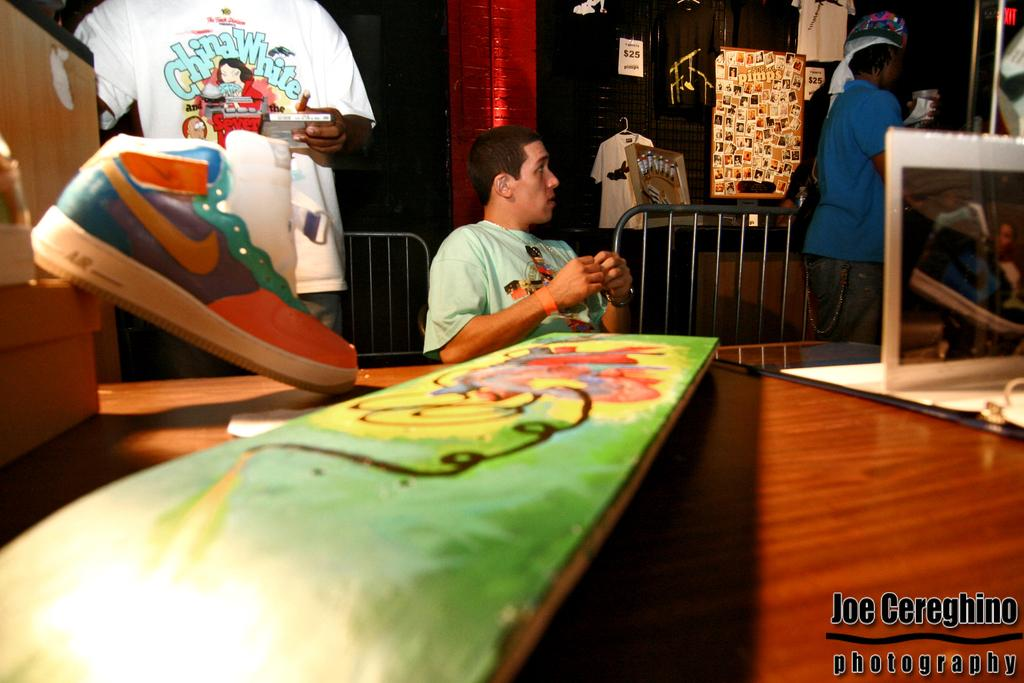<image>
Relay a brief, clear account of the picture shown. Art work with a tshirt that has China White in blue lettering. 